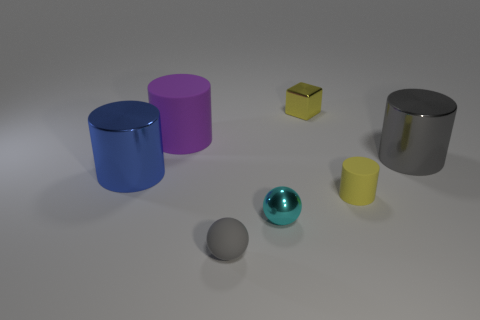Can you describe the different materials and how they affect the appearance of objects? Certainly! In this image, we can observe objects with varying materials. The objects appear to have matte, metallic, and shiny surfaces. Matte surfaces, like the yellow cube, scatter light, giving them a soft, non-reflective finish. The blue and gray cylinders have a metallic sheen, suggesting a smooth surface that reflects light with highlights and shadows that accentuate their cylindrical shapes. Lastly, the cyan sphere has a shiny, almost glossy surface, reflecting its surroundings with a clear, mirror-like quality that enhances its spherical form. 